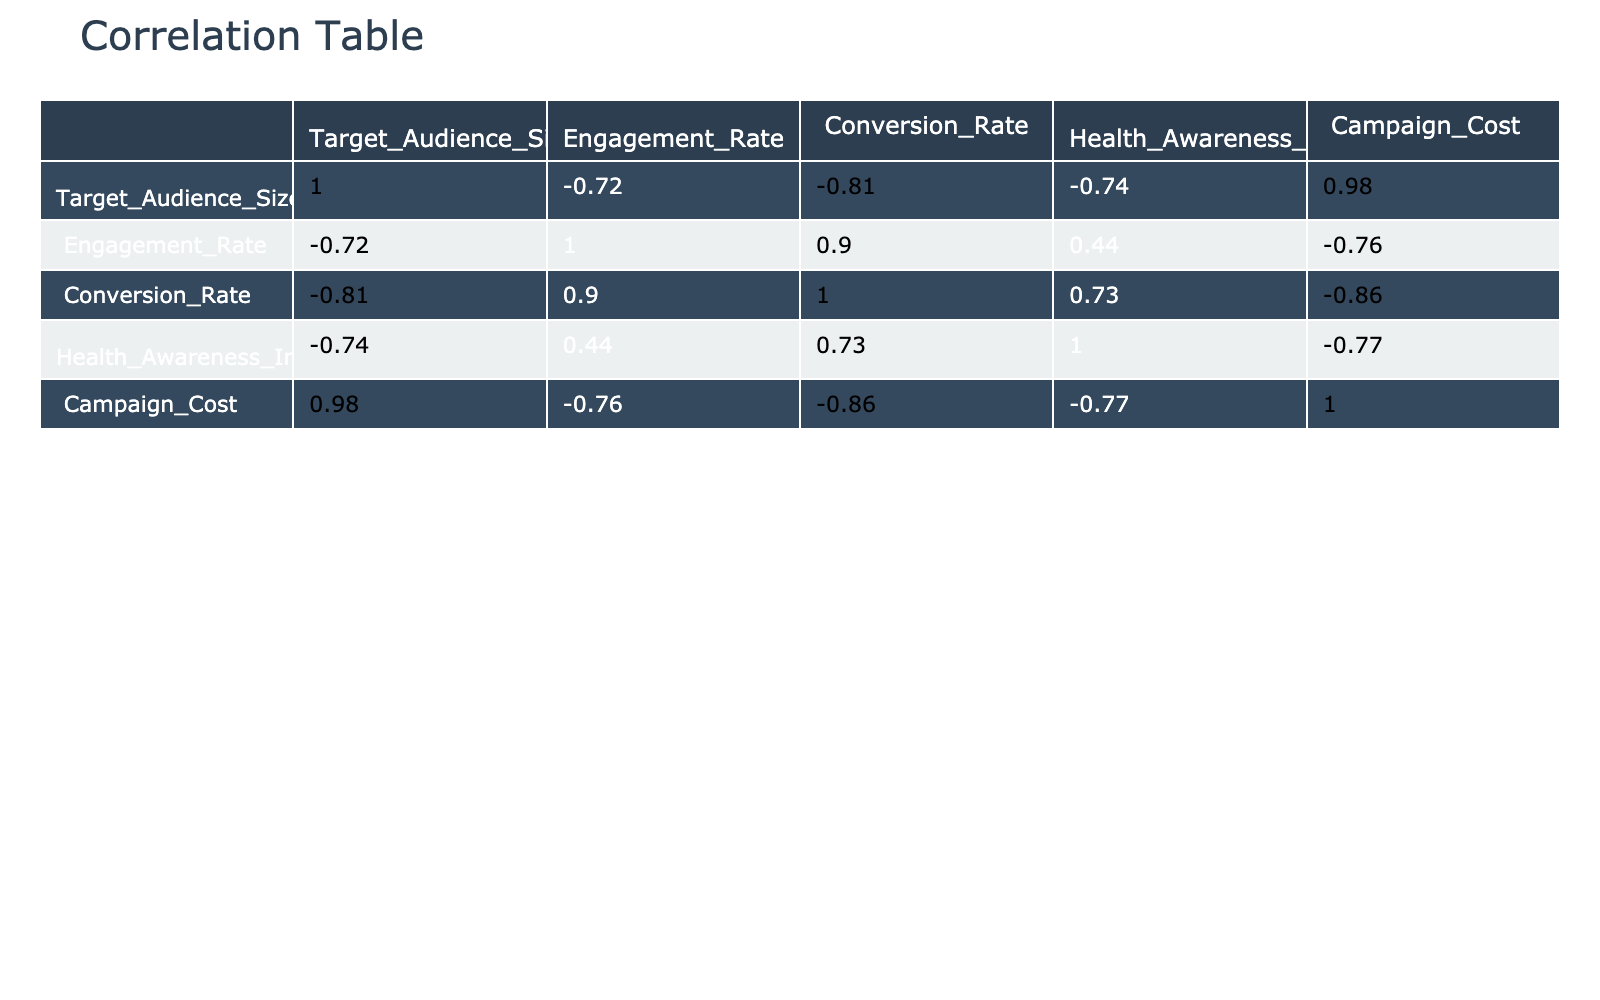What is the engagement rate of the "Tobacco Cessation Program"? The engagement rate is directly listed under the "Engagement Rate" column for the "Tobacco Cessation Program" row, which is 0.30.
Answer: 0.30 What is the highest Health Awareness Index among the campaigns? I look at the "Health Awareness Index" column and identify the maximum value, which is 90 for the "Mental Health Awareness" campaign.
Answer: 90 What is the average conversion rate of all campaigns? To find the average, I sum up all the conversion rates: (0.12 + 0.08 + 0.15 + 0.10 + 0.20 + 0.11 + 0.18 + 0.09) = 1.03. There are 8 campaigns, so the average conversion rate is 1.03 / 8 = 0.12875, which rounds to 0.13.
Answer: 0.13 Is the campaign "Sun Safety Campaign" more effective in terms of conversion rate than "Vaccination Awareness"? I compare the conversion rates for both: "Sun Safety Campaign" has a conversion rate of 0.11, while "Vaccination Awareness" has 0.10. Since 0.11 is greater than 0.10, I conclude it is more effective.
Answer: Yes Which advertising strategy has the highest average engagement rate? First, I find the engagement rates for each strategy: "Social Media Influencer" (0.45), "Television Ads" (0.30), "Community Events" (0.50), "Billboard Advertising" (0.25), "Online Webinars" (0.60), "Print Media" (0.35), "School Programs" (0.55), "Public Service Announcements" (0.40). The highest is for "Online Webinars" with an engagement rate of 0.60.
Answer: Online Webinars Which two campaigns have the closest Health Awareness Index values? I scan the "Health Awareness Index" column for the smallest difference between values. "Anti-Obesity Initiative" (78) and "Healthy Eating Initiative" (75) have a difference of 3, which is the closest among all pairs.
Answer: Anti-Obesity Initiative and Healthy Eating Initiative What is the total cost of campaigns that use "Print Media" and "Community Events"? I look at the "Campaign Cost" for "Print Media" (25000) and "Community Events" (15000). The total cost is 25000 + 15000 = 40000.
Answer: 40000 Is there any campaign with an engagement rate greater than 0.50 that also has a conversion rate above 0.15? I check the "Engagement Rate" and "Conversion Rate" columns. The only campaign that satisfies both conditions is "Mental Health Awareness" with an engagement rate of 0.60 and a conversion rate of 0.20.
Answer: Yes Which advertising strategy has the least target audience size? I review the "Target Audience Size" column and identify the smallest value, which is 10000 for the "Mental Health Awareness" campaign.
Answer: Mental Health Awareness 